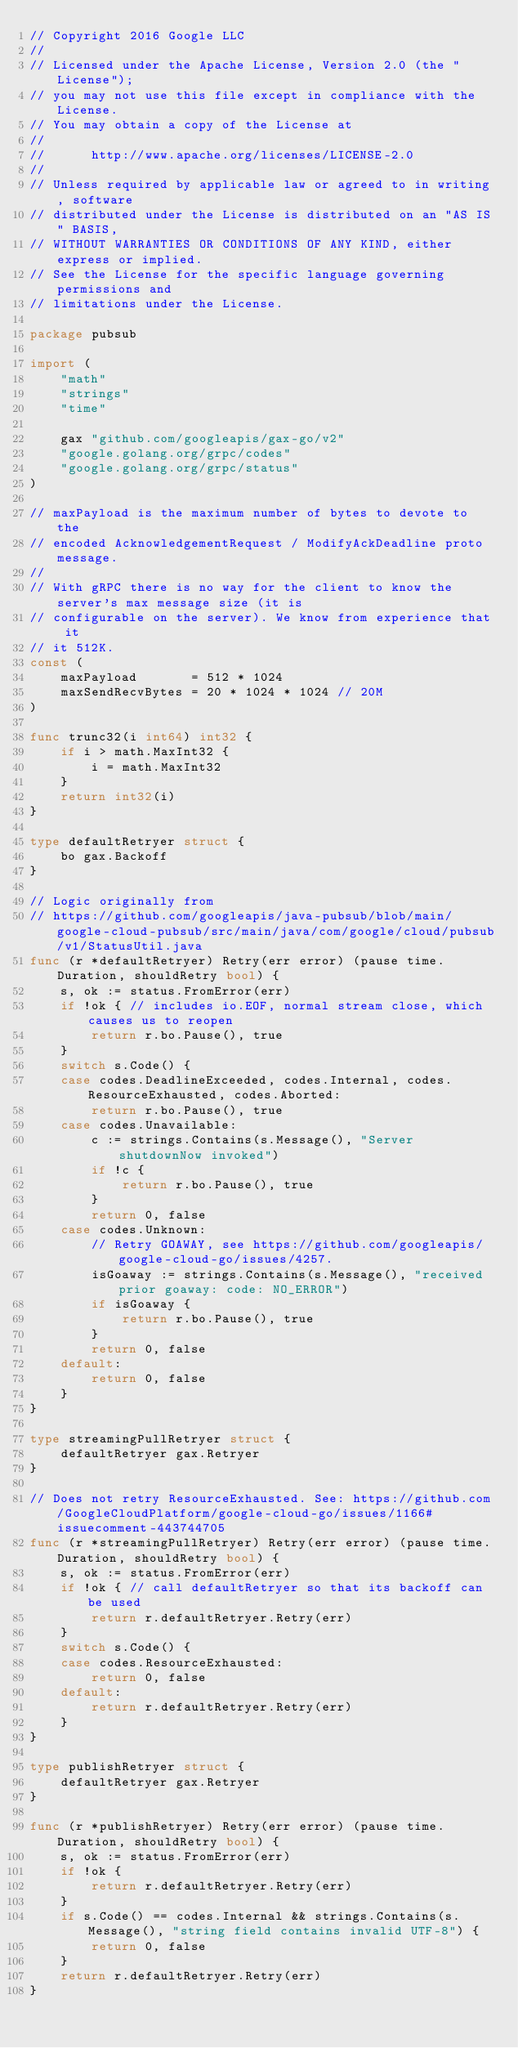Convert code to text. <code><loc_0><loc_0><loc_500><loc_500><_Go_>// Copyright 2016 Google LLC
//
// Licensed under the Apache License, Version 2.0 (the "License");
// you may not use this file except in compliance with the License.
// You may obtain a copy of the License at
//
//      http://www.apache.org/licenses/LICENSE-2.0
//
// Unless required by applicable law or agreed to in writing, software
// distributed under the License is distributed on an "AS IS" BASIS,
// WITHOUT WARRANTIES OR CONDITIONS OF ANY KIND, either express or implied.
// See the License for the specific language governing permissions and
// limitations under the License.

package pubsub

import (
	"math"
	"strings"
	"time"

	gax "github.com/googleapis/gax-go/v2"
	"google.golang.org/grpc/codes"
	"google.golang.org/grpc/status"
)

// maxPayload is the maximum number of bytes to devote to the
// encoded AcknowledgementRequest / ModifyAckDeadline proto message.
//
// With gRPC there is no way for the client to know the server's max message size (it is
// configurable on the server). We know from experience that it
// it 512K.
const (
	maxPayload       = 512 * 1024
	maxSendRecvBytes = 20 * 1024 * 1024 // 20M
)

func trunc32(i int64) int32 {
	if i > math.MaxInt32 {
		i = math.MaxInt32
	}
	return int32(i)
}

type defaultRetryer struct {
	bo gax.Backoff
}

// Logic originally from
// https://github.com/googleapis/java-pubsub/blob/main/google-cloud-pubsub/src/main/java/com/google/cloud/pubsub/v1/StatusUtil.java
func (r *defaultRetryer) Retry(err error) (pause time.Duration, shouldRetry bool) {
	s, ok := status.FromError(err)
	if !ok { // includes io.EOF, normal stream close, which causes us to reopen
		return r.bo.Pause(), true
	}
	switch s.Code() {
	case codes.DeadlineExceeded, codes.Internal, codes.ResourceExhausted, codes.Aborted:
		return r.bo.Pause(), true
	case codes.Unavailable:
		c := strings.Contains(s.Message(), "Server shutdownNow invoked")
		if !c {
			return r.bo.Pause(), true
		}
		return 0, false
	case codes.Unknown:
		// Retry GOAWAY, see https://github.com/googleapis/google-cloud-go/issues/4257.
		isGoaway := strings.Contains(s.Message(), "received prior goaway: code: NO_ERROR")
		if isGoaway {
			return r.bo.Pause(), true
		}
		return 0, false
	default:
		return 0, false
	}
}

type streamingPullRetryer struct {
	defaultRetryer gax.Retryer
}

// Does not retry ResourceExhausted. See: https://github.com/GoogleCloudPlatform/google-cloud-go/issues/1166#issuecomment-443744705
func (r *streamingPullRetryer) Retry(err error) (pause time.Duration, shouldRetry bool) {
	s, ok := status.FromError(err)
	if !ok { // call defaultRetryer so that its backoff can be used
		return r.defaultRetryer.Retry(err)
	}
	switch s.Code() {
	case codes.ResourceExhausted:
		return 0, false
	default:
		return r.defaultRetryer.Retry(err)
	}
}

type publishRetryer struct {
	defaultRetryer gax.Retryer
}

func (r *publishRetryer) Retry(err error) (pause time.Duration, shouldRetry bool) {
	s, ok := status.FromError(err)
	if !ok {
		return r.defaultRetryer.Retry(err)
	}
	if s.Code() == codes.Internal && strings.Contains(s.Message(), "string field contains invalid UTF-8") {
		return 0, false
	}
	return r.defaultRetryer.Retry(err)
}
</code> 